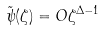Convert formula to latex. <formula><loc_0><loc_0><loc_500><loc_500>\tilde { \psi } ( \zeta ) = O \zeta ^ { \Delta - 1 }</formula> 